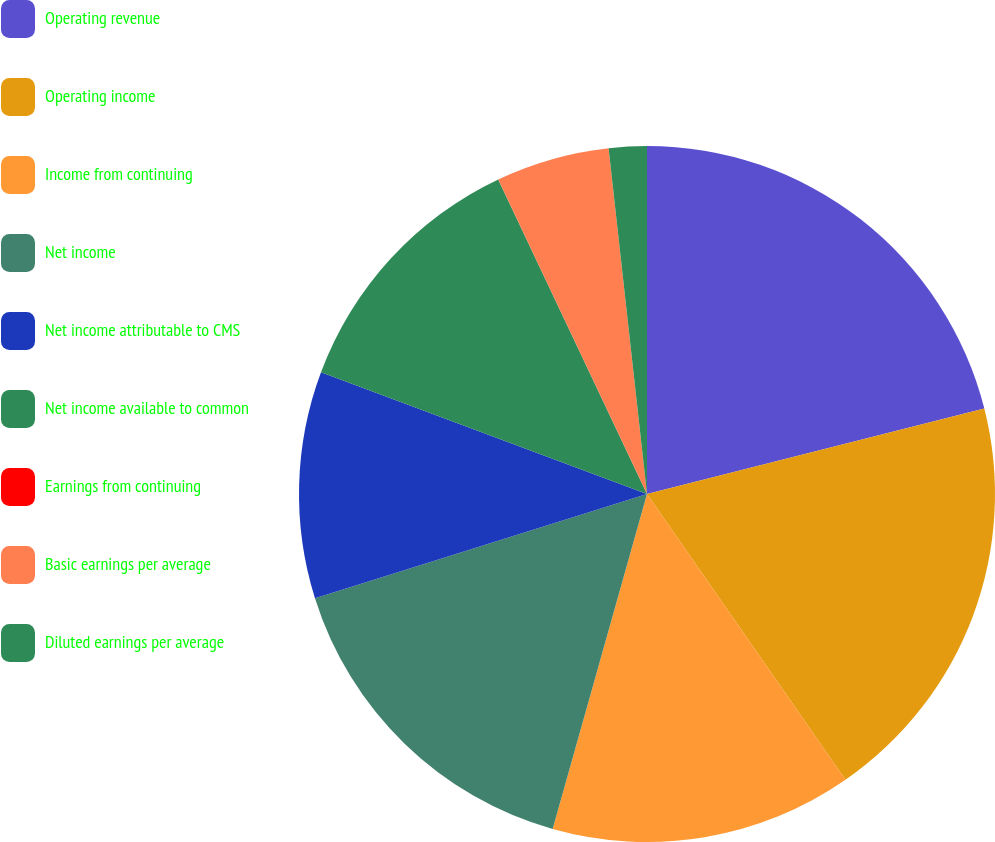Convert chart. <chart><loc_0><loc_0><loc_500><loc_500><pie_chart><fcel>Operating revenue<fcel>Operating income<fcel>Income from continuing<fcel>Net income<fcel>Net income attributable to CMS<fcel>Net income available to common<fcel>Earnings from continuing<fcel>Basic earnings per average<fcel>Diluted earnings per average<nl><fcel>21.05%<fcel>19.29%<fcel>14.03%<fcel>15.79%<fcel>10.53%<fcel>12.28%<fcel>0.0%<fcel>5.27%<fcel>1.76%<nl></chart> 